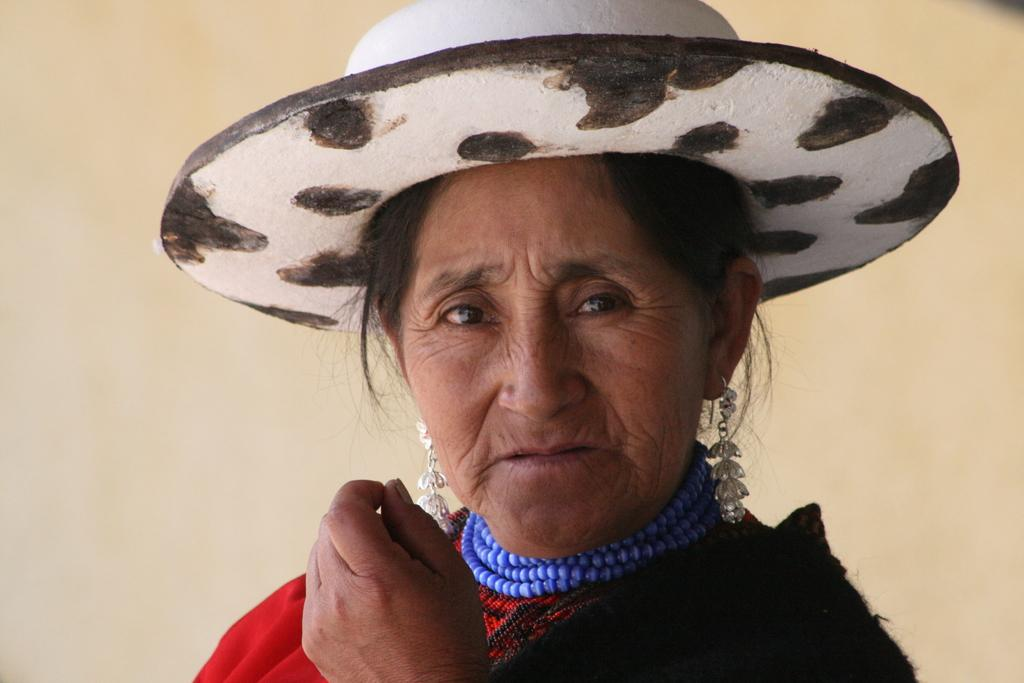Who is present in the image? There is a lady in the image. What is the lady wearing on her head? The lady is wearing a hat. What can be seen in the background of the image? There is a wall in the image. How many rabbits are sitting on the dock in the image? There is no dock or rabbits present in the image. What time of day is it in the image, based on the hour? The provided facts do not mention the time of day or any hour, so it cannot be determined from the image. 